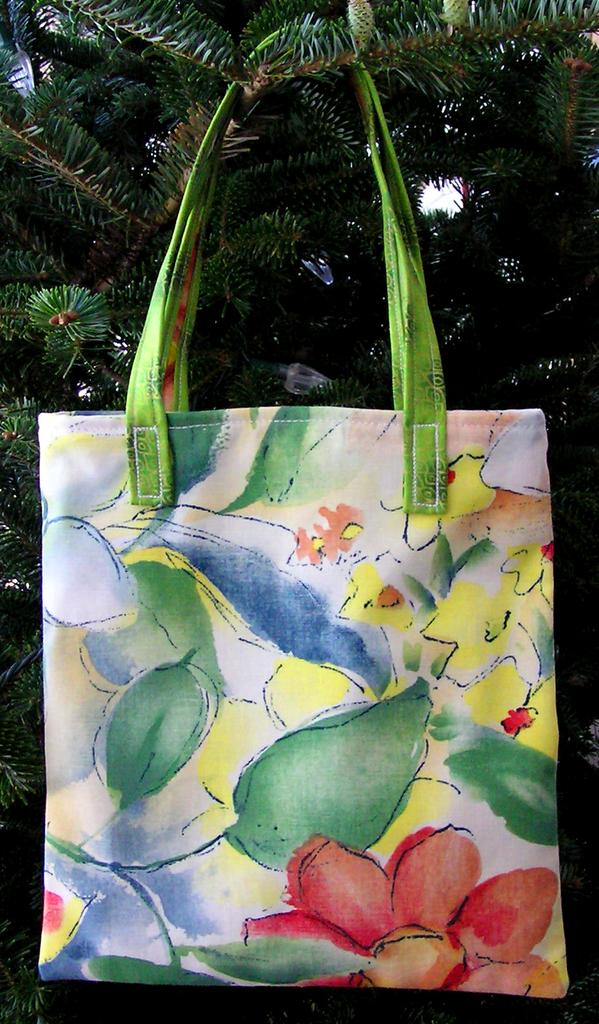What object is hanging from a tree in the image? There is a bag hanging from a tree in the image. What type of business is being conducted in the image? There is no indication of any business being conducted in the image; it only shows a bag hanging from a tree. 